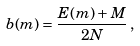<formula> <loc_0><loc_0><loc_500><loc_500>b ( m ) = \frac { E ( m ) + M } { 2 N } \, ,</formula> 